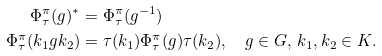Convert formula to latex. <formula><loc_0><loc_0><loc_500><loc_500>\Phi ^ { \pi } _ { \tau } ( g ) ^ { * } & = \Phi ^ { \pi } _ { \tau } ( g ^ { - 1 } ) \\ \Phi ^ { \pi } _ { \tau } ( k _ { 1 } g k _ { 2 } ) & = \tau ( k _ { 1 } ) \Phi ^ { \pi } _ { \tau } ( g ) \tau ( k _ { 2 } ) , \quad g \in G , \, k _ { 1 } , k _ { 2 } \in K .</formula> 